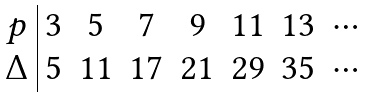<formula> <loc_0><loc_0><loc_500><loc_500>\begin{array} { c | c c c c c c c } p & 3 & 5 & 7 & 9 & 1 1 & 1 3 & \cdots \\ \Delta & 5 & 1 1 & 1 7 & 2 1 & 2 9 & 3 5 & \cdots \end{array}</formula> 